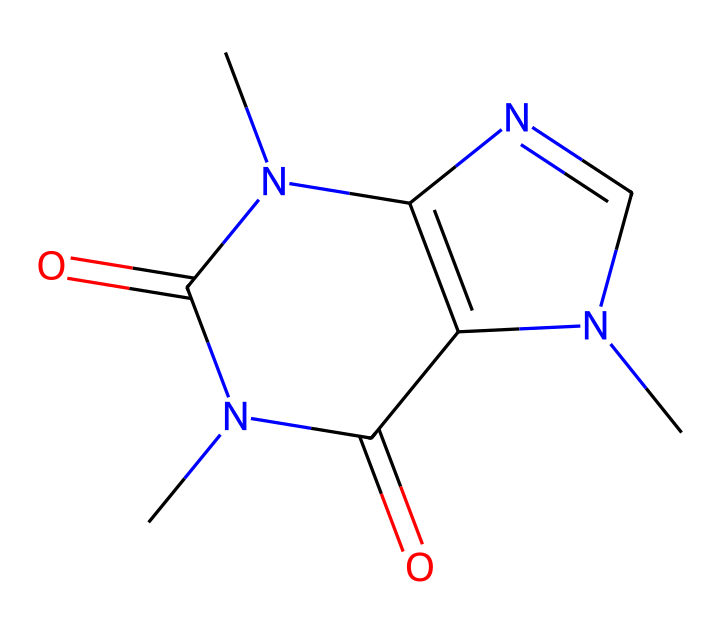What is the name of this chemical? The SMILES representation corresponds to caffeine, which is widely recognized as a stimulant found in coffee and tea. This is confirmed by recognizing the specific structure characteristic of caffeine, including the arrangement of its atoms and functional groups.
Answer: caffeine How many nitrogen atoms are present in this structure? By analyzing the chemical structure from the SMILES notation, we can count that there are four nitrogen atoms depicted, which are pivotal in defining its biochemical properties.
Answer: four What type of chemical is caffeine classified as? Caffeine is classified as an alkaloid, which is a type of naturally occurring compound containing basic nitrogen atoms. This classification is based on its structure that includes nitrogen atoms, which is typical for alkaloids.
Answer: alkaloid How many rings are present in the structure of caffeine? Upon examining the SMILES representation, we can determine that caffeine contains two fused bicyclic rings, evidenced by the interconnected cyclic components in its structure.
Answer: two Does this chemical contain any functional groups? Yes, the structure of caffeine includes carbonyl functional groups, specifically two keto groups (C=O), identifiable from the position of the oxygen in relation to the carbon atoms in the SMILES representation.
Answer: yes What is the molecular formula for caffeine? By translating the composition found in the SMILES representation into a molecular formula, caffeine is confirmed to have the molecular formula C8H10N4O2, which reflects the atoms present in the structure.
Answer: C8H10N4O2 